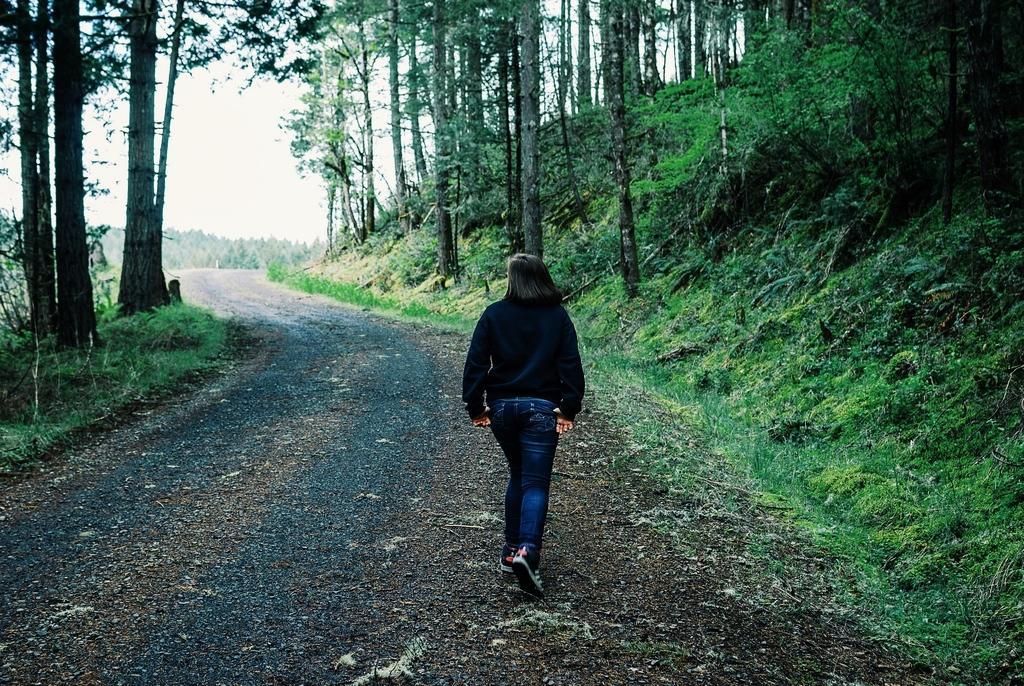Describe this image in one or two sentences. In this picture I can see a woman is walking on the road. The woman is wearing black color top and blue jeans. Here I can see trees, plants and the grass. In the background I can see the sky. 